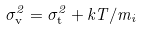Convert formula to latex. <formula><loc_0><loc_0><loc_500><loc_500>\sigma _ { \mathrm v } ^ { 2 } = \sigma _ { \mathrm t } ^ { 2 } + k T / m _ { i }</formula> 